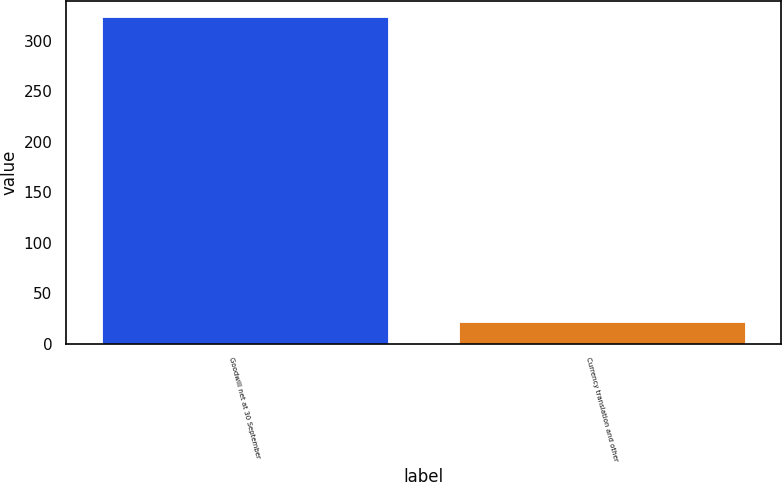Convert chart to OTSL. <chart><loc_0><loc_0><loc_500><loc_500><bar_chart><fcel>Goodwill net at 30 September<fcel>Currency translation and other<nl><fcel>323.62<fcel>21.2<nl></chart> 